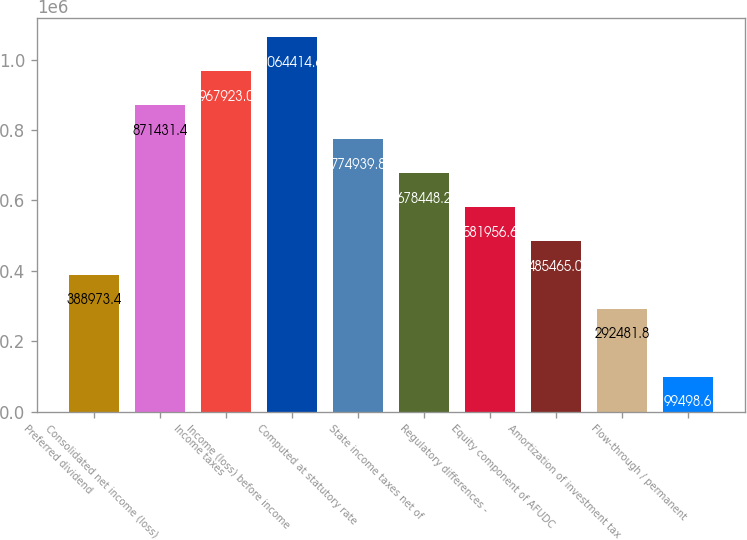Convert chart. <chart><loc_0><loc_0><loc_500><loc_500><bar_chart><fcel>Preferred dividend<fcel>Consolidated net income (loss)<fcel>Income taxes<fcel>Income (loss) before income<fcel>Computed at statutory rate<fcel>State income taxes net of<fcel>Regulatory differences -<fcel>Equity component of AFUDC<fcel>Amortization of investment tax<fcel>Flow-through / permanent<nl><fcel>388973<fcel>871431<fcel>967923<fcel>1.06441e+06<fcel>774940<fcel>678448<fcel>581957<fcel>485465<fcel>292482<fcel>99498.6<nl></chart> 